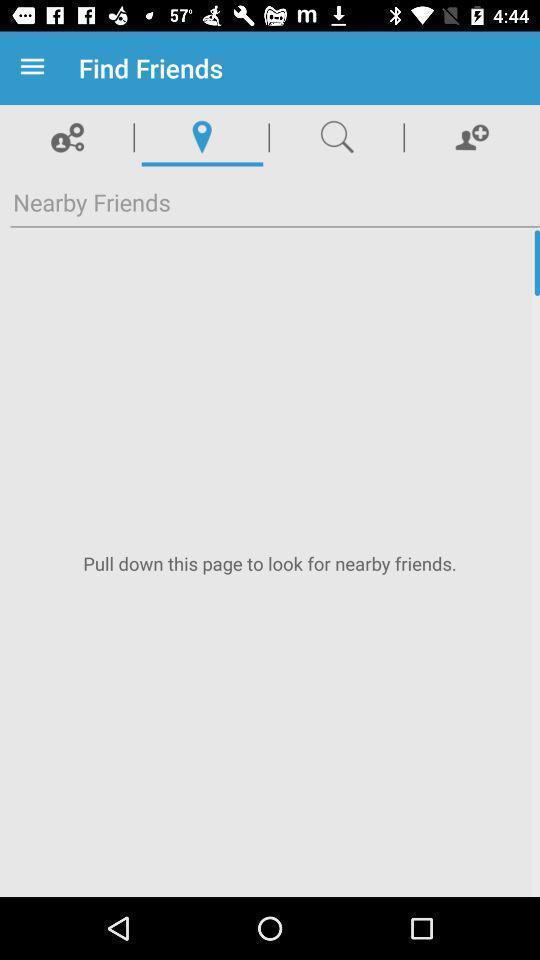Tell me what you see in this picture. Screen shows to find friends. 